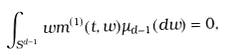<formula> <loc_0><loc_0><loc_500><loc_500>\int _ { S ^ { d - 1 } } w m ^ { ( 1 ) } ( t , w ) \mu _ { d - 1 } ( d w ) = 0 ,</formula> 